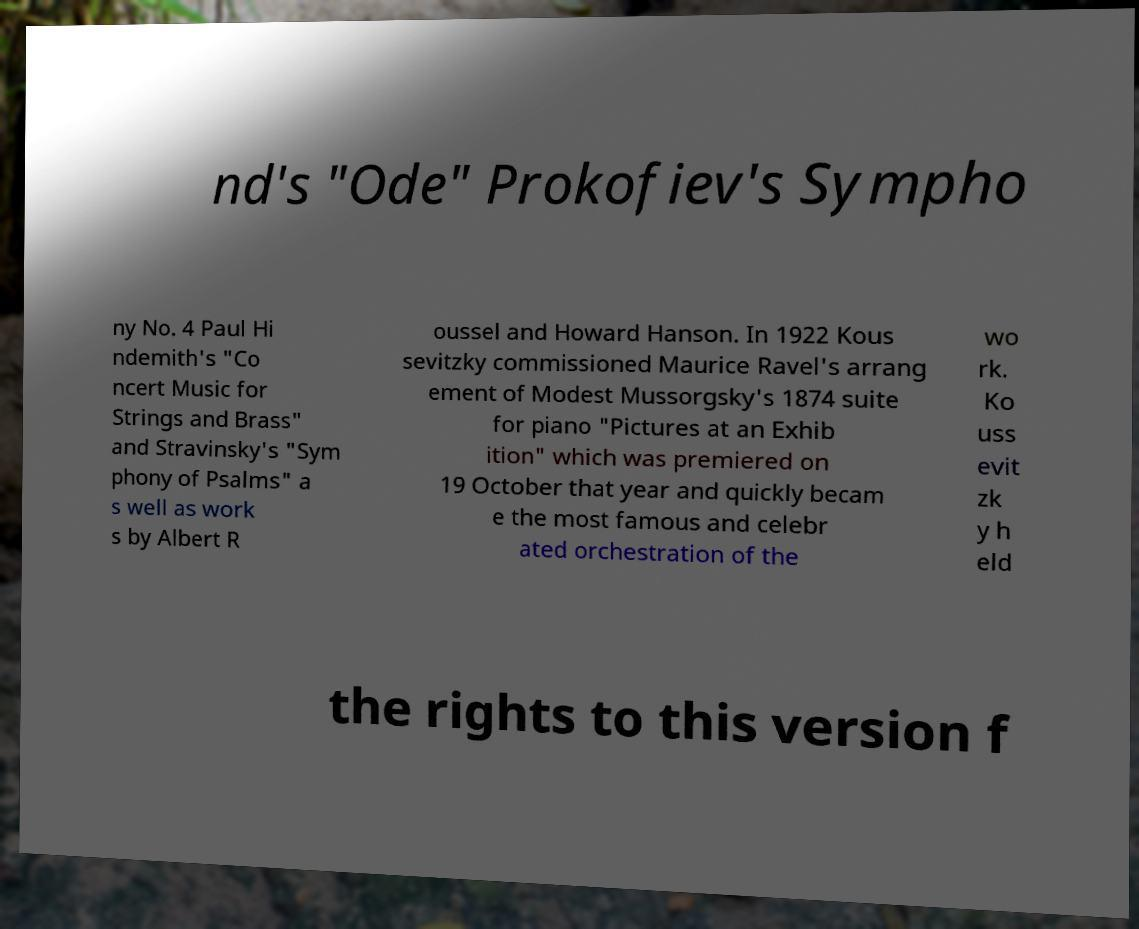Can you accurately transcribe the text from the provided image for me? nd's "Ode" Prokofiev's Sympho ny No. 4 Paul Hi ndemith's "Co ncert Music for Strings and Brass" and Stravinsky's "Sym phony of Psalms" a s well as work s by Albert R oussel and Howard Hanson. In 1922 Kous sevitzky commissioned Maurice Ravel's arrang ement of Modest Mussorgsky's 1874 suite for piano "Pictures at an Exhib ition" which was premiered on 19 October that year and quickly becam e the most famous and celebr ated orchestration of the wo rk. Ko uss evit zk y h eld the rights to this version f 